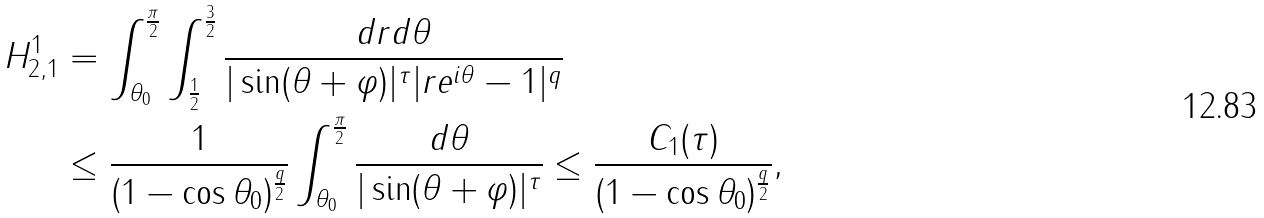Convert formula to latex. <formula><loc_0><loc_0><loc_500><loc_500>H _ { 2 , 1 } ^ { 1 } & = \int _ { \theta _ { 0 } } ^ { \frac { \pi } { 2 } } \int _ { \frac { 1 } { 2 } } ^ { \frac { 3 } { 2 } } \frac { d r d \theta } { | \sin ( \theta + \varphi ) | ^ { \tau } | r e ^ { i \theta } - 1 | ^ { q } } \\ & \leq \frac { 1 } { ( 1 - \cos \theta _ { 0 } ) ^ { \frac { q } { 2 } } } \int _ { \theta _ { 0 } } ^ { \frac { \pi } { 2 } } \frac { d \theta } { | \sin ( \theta + \varphi ) | ^ { \tau } } \leq \frac { C _ { 1 } ( \tau ) } { ( 1 - \cos \theta _ { 0 } ) ^ { \frac { q } { 2 } } } ,</formula> 